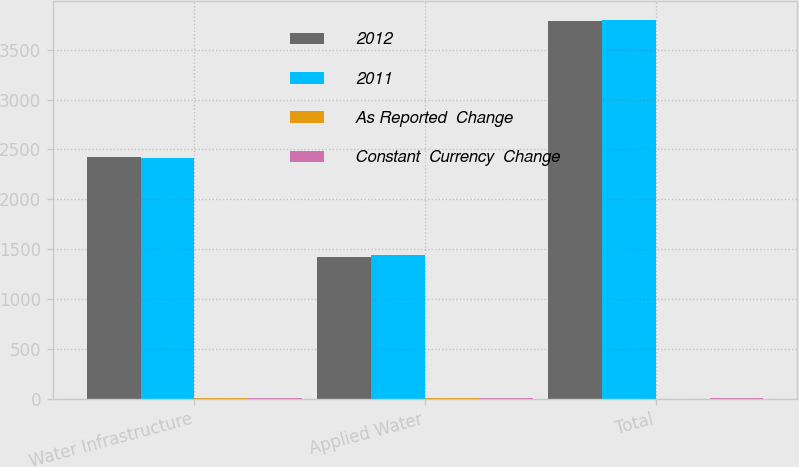<chart> <loc_0><loc_0><loc_500><loc_500><stacked_bar_chart><ecel><fcel>Water Infrastructure<fcel>Applied Water<fcel>Total<nl><fcel>2012<fcel>2425<fcel>1424<fcel>3791<nl><fcel>2011<fcel>2416<fcel>1444<fcel>3803<nl><fcel>As Reported  Change<fcel>0.4<fcel>1.4<fcel>0.3<nl><fcel>Constant  Currency  Change<fcel>3.7<fcel>0.8<fcel>2.5<nl></chart> 